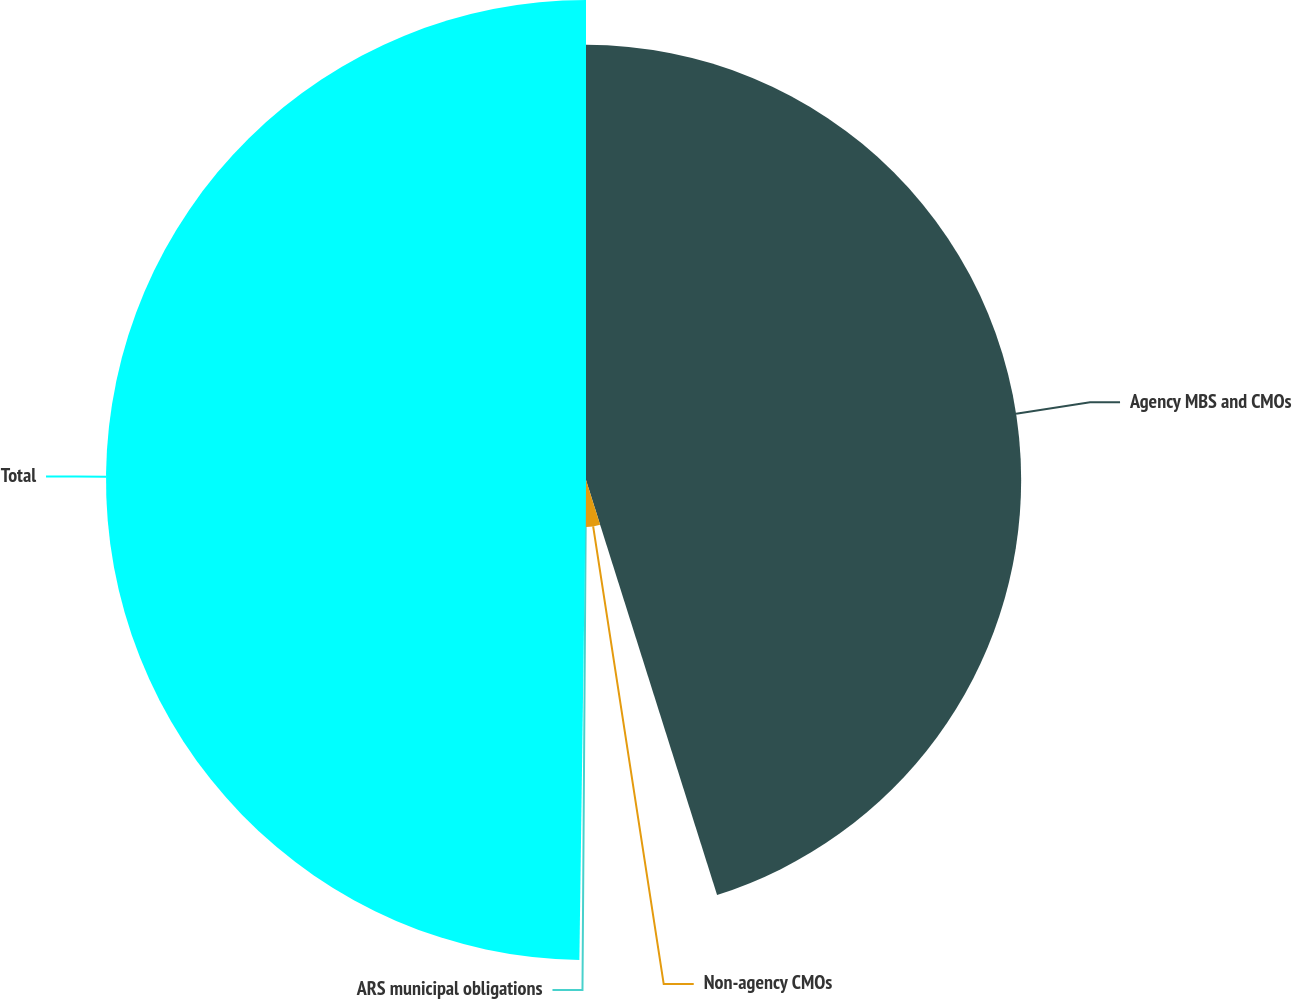Convert chart to OTSL. <chart><loc_0><loc_0><loc_500><loc_500><pie_chart><fcel>Agency MBS and CMOs<fcel>Non-agency CMOs<fcel>ARS municipal obligations<fcel>Total<nl><fcel>45.13%<fcel>4.87%<fcel>0.22%<fcel>49.78%<nl></chart> 